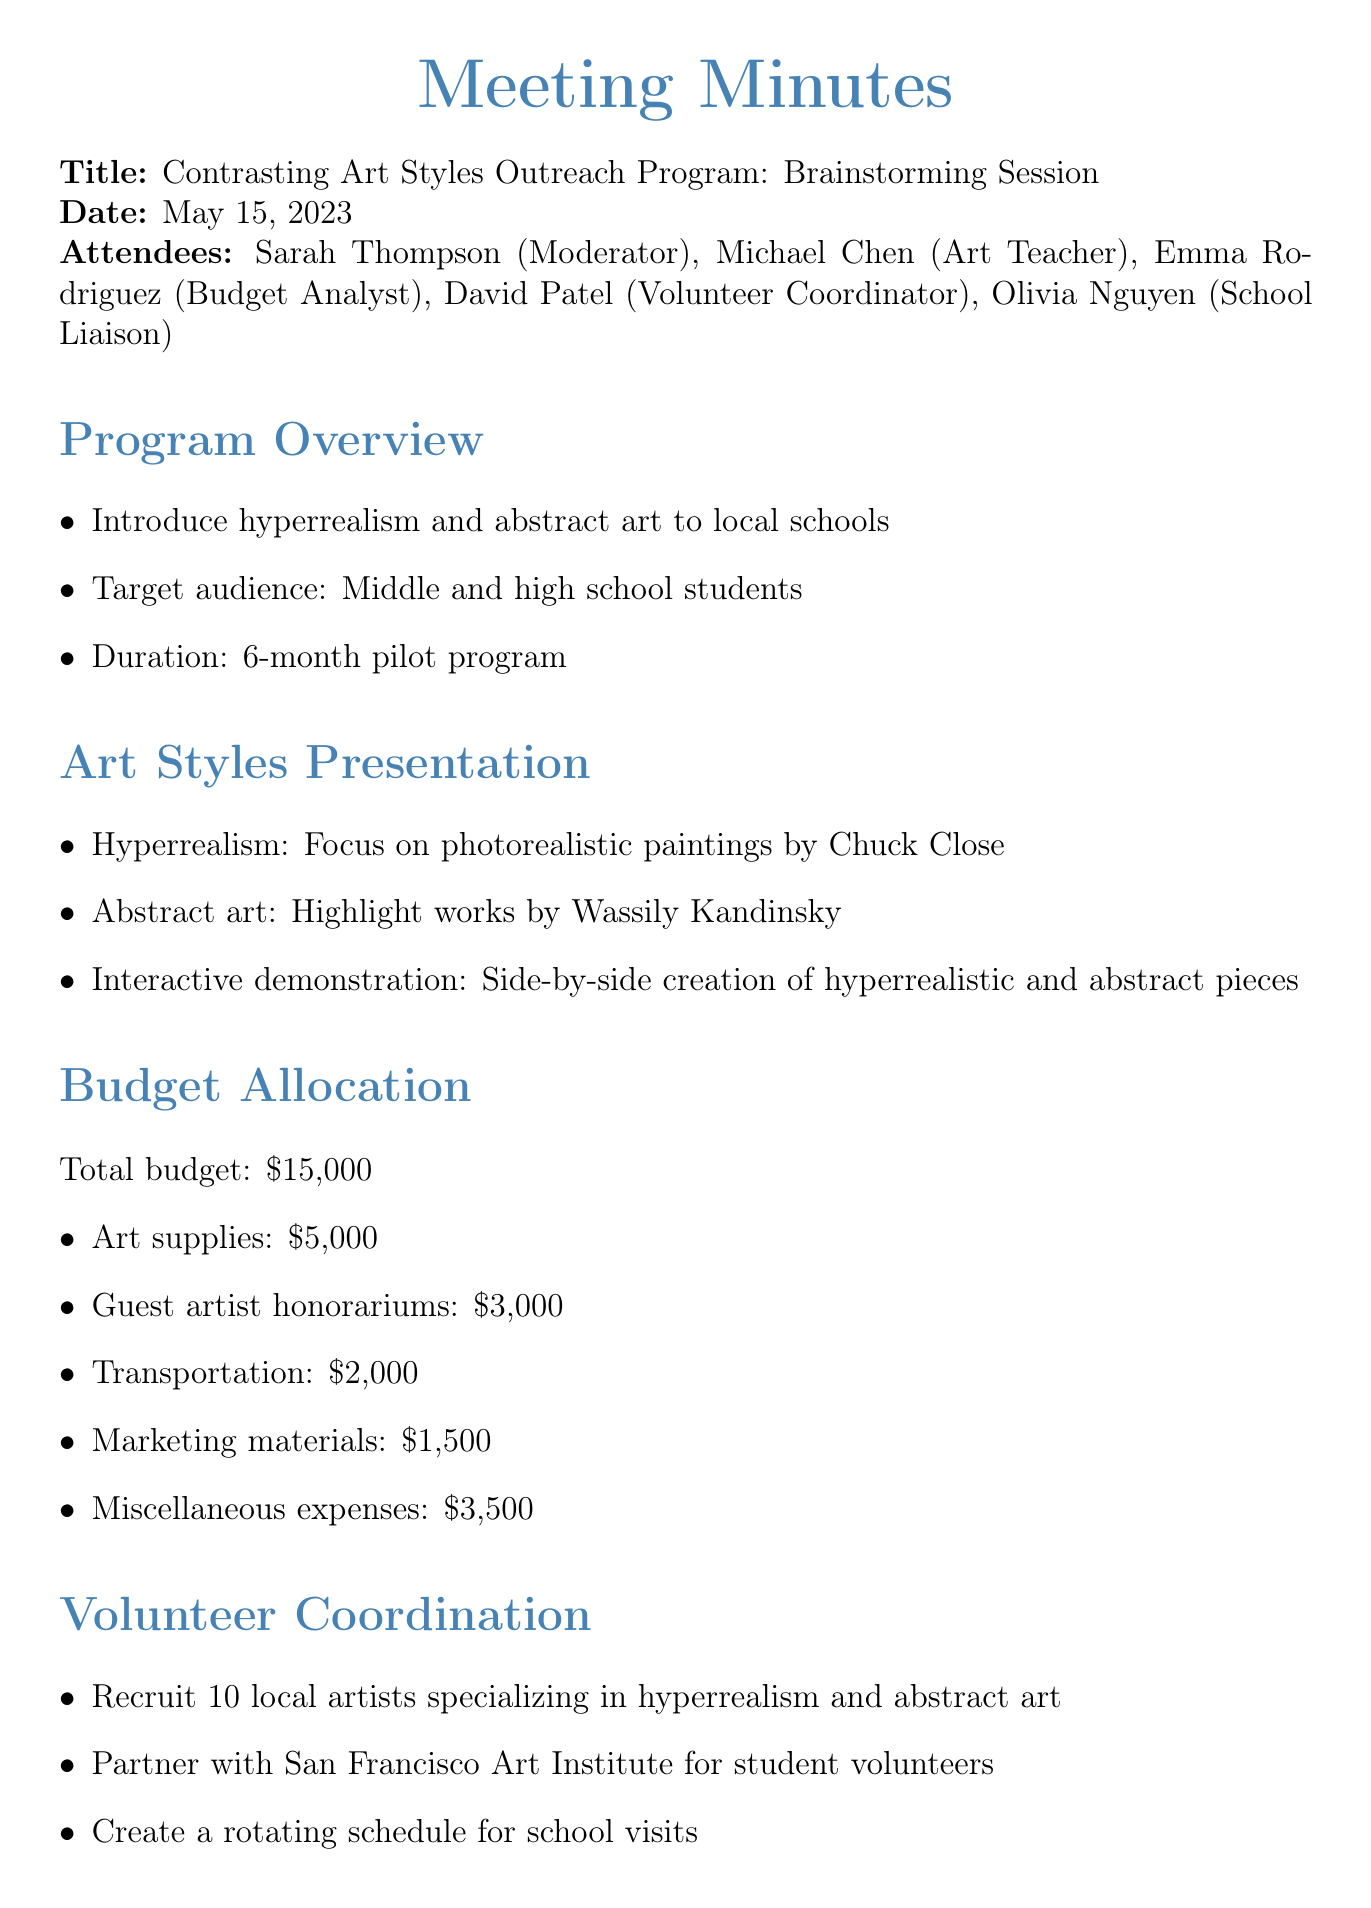What is the meeting date? The meeting date is clearly stated in the document.
Answer: May 15, 2023 Who is the moderator of the meeting? The document lists the attendees, and Sarah Thompson is mentioned as the moderator.
Answer: Sarah Thompson What is the total budget for the program? The total budget amount is specified in the budget allocation section of the document.
Answer: $15,000 How many local artists will be recruited? The volunteer coordination section states the number of local artists to be recruited.
Answer: 10 Which artist's work is highlighted for hyperrealism? The document specifically mentions Chuck Close in the art styles presentation.
Answer: Chuck Close What is one of the next steps mentioned for the program? The next steps section outlines several future actions, which include finalizing details among others.
Answer: Finalize school list with Olivia Which art style is associated with Wassily Kandinsky? The document specifically associates abstract art with Wassily Kandinsky in the presentation section.
Answer: Abstract art What is the budget allocation for art supplies? The budget allocation section details the amount allocated for art supplies.
Answer: $5,000 What type of students is the program targeting? The program overview specifies the target audience for the outreach program.
Answer: Middle and high school students 